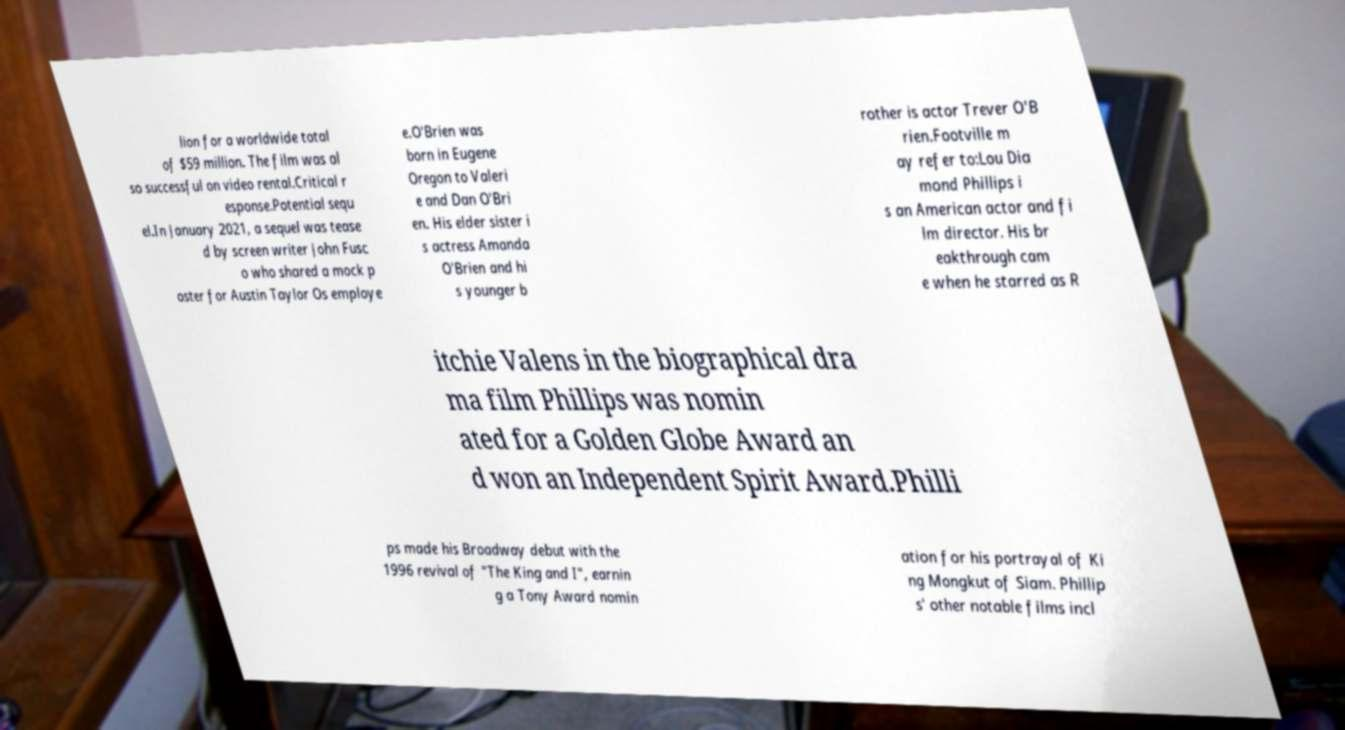For documentation purposes, I need the text within this image transcribed. Could you provide that? lion for a worldwide total of $59 million. The film was al so successful on video rental.Critical r esponse.Potential sequ el.In January 2021, a sequel was tease d by screen writer John Fusc o who shared a mock p oster for Austin Taylor Os employe e.O'Brien was born in Eugene Oregon to Valeri e and Dan O'Bri en. His elder sister i s actress Amanda O'Brien and hi s younger b rother is actor Trever O'B rien.Footville m ay refer to:Lou Dia mond Phillips i s an American actor and fi lm director. His br eakthrough cam e when he starred as R itchie Valens in the biographical dra ma film Phillips was nomin ated for a Golden Globe Award an d won an Independent Spirit Award.Philli ps made his Broadway debut with the 1996 revival of "The King and I", earnin g a Tony Award nomin ation for his portrayal of Ki ng Mongkut of Siam. Phillip s' other notable films incl 